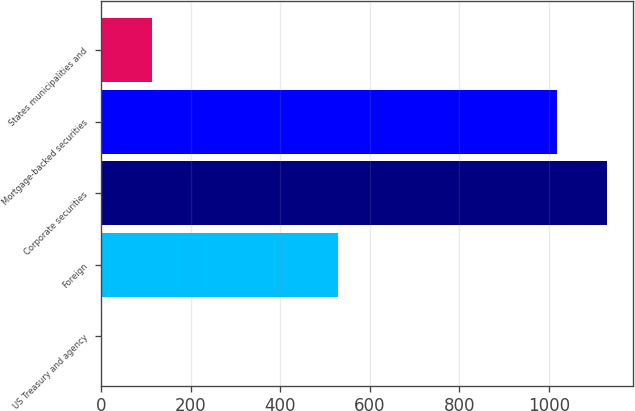<chart> <loc_0><loc_0><loc_500><loc_500><bar_chart><fcel>US Treasury and agency<fcel>Foreign<fcel>Corporate securities<fcel>Mortgage-backed securities<fcel>States municipalities and<nl><fcel>2<fcel>529<fcel>1130.9<fcel>1019<fcel>113.9<nl></chart> 